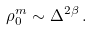<formula> <loc_0><loc_0><loc_500><loc_500>\rho _ { 0 } ^ { m } \sim \Delta ^ { 2 \beta } \, .</formula> 